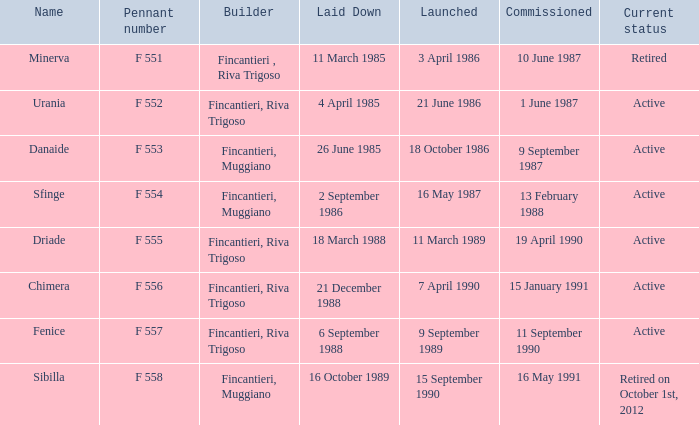Write the full table. {'header': ['Name', 'Pennant number', 'Builder', 'Laid Down', 'Launched', 'Commissioned', 'Current status'], 'rows': [['Minerva', 'F 551', 'Fincantieri , Riva Trigoso', '11 March 1985', '3 April 1986', '10 June 1987', 'Retired'], ['Urania', 'F 552', 'Fincantieri, Riva Trigoso', '4 April 1985', '21 June 1986', '1 June 1987', 'Active'], ['Danaide', 'F 553', 'Fincantieri, Muggiano', '26 June 1985', '18 October 1986', '9 September 1987', 'Active'], ['Sfinge', 'F 554', 'Fincantieri, Muggiano', '2 September 1986', '16 May 1987', '13 February 1988', 'Active'], ['Driade', 'F 555', 'Fincantieri, Riva Trigoso', '18 March 1988', '11 March 1989', '19 April 1990', 'Active'], ['Chimera', 'F 556', 'Fincantieri, Riva Trigoso', '21 December 1988', '7 April 1990', '15 January 1991', 'Active'], ['Fenice', 'F 557', 'Fincantieri, Riva Trigoso', '6 September 1988', '9 September 1989', '11 September 1990', 'Active'], ['Sibilla', 'F 558', 'Fincantieri, Muggiano', '16 October 1989', '15 September 1990', '16 May 1991', 'Retired on October 1st, 2012']]} What is the name of the builder who launched in danaide 18 October 1986. 